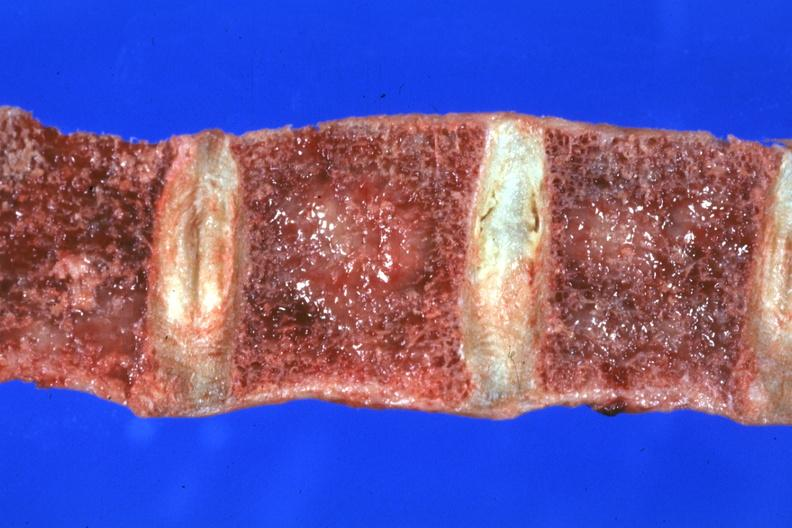does multiple myeloma show close-up view of frontal section vertebral bodies excellent?
Answer the question using a single word or phrase. No 